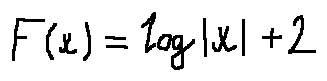<formula> <loc_0><loc_0><loc_500><loc_500>F ( x ) = \log | x | + 2</formula> 